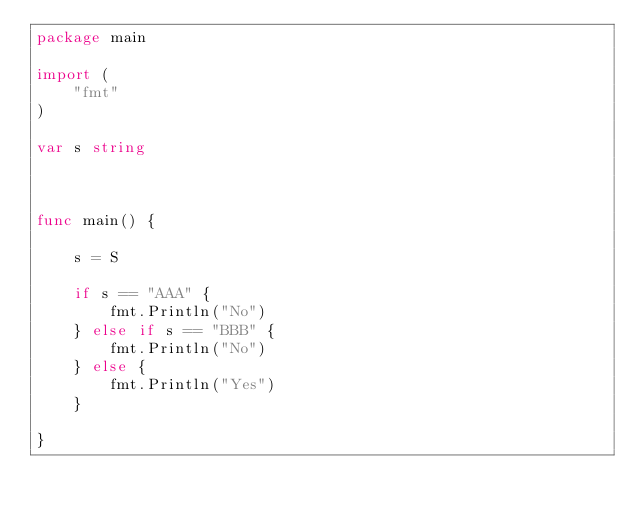<code> <loc_0><loc_0><loc_500><loc_500><_Go_>package main

import (
	"fmt"
)

var s string



func main() {
	
	s = S
	
	if s == "AAA" {
		fmt.Println("No")
	} else if s == "BBB" {
		fmt.Println("No")
	} else {
		fmt.Println("Yes")
	}

}</code> 